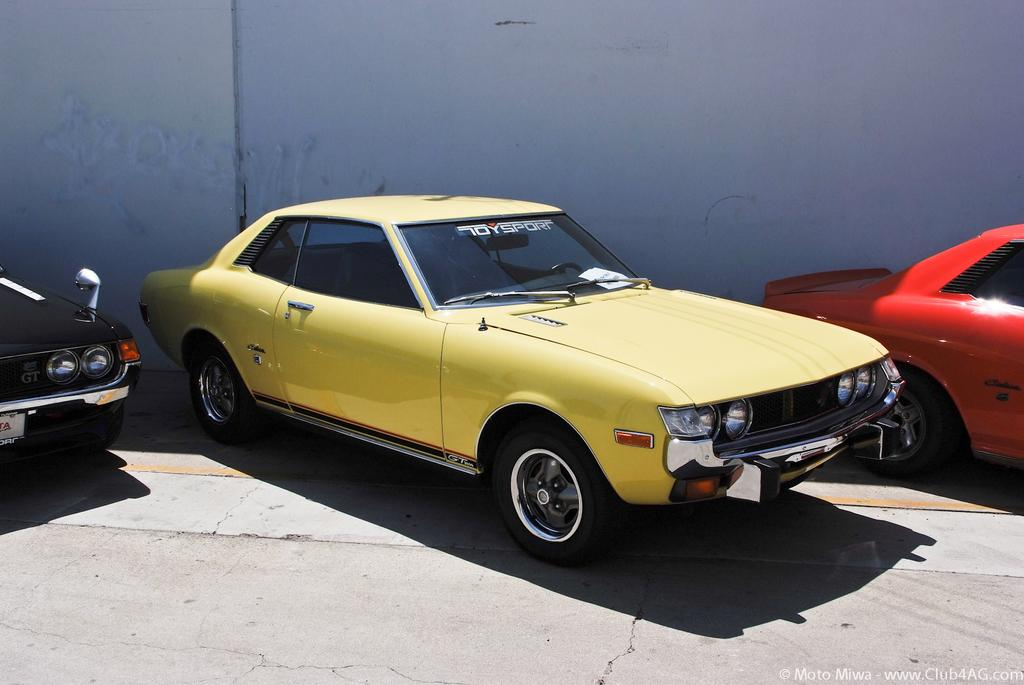What type of vehicles can be seen in the image? There are cars in the image. Can you describe any specific details about the cars? There is writing on the windshield of one of the cars. Is there any additional information visible in the image? Yes, there is a watermark visible in the image. What type of gun is being used in the meeting depicted in the image? There is no meeting or gun present in the image; it features cars and a watermark. 